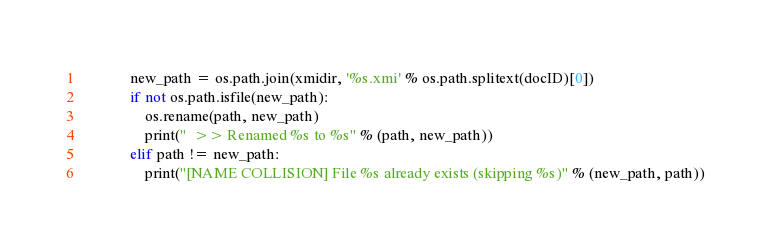Convert code to text. <code><loc_0><loc_0><loc_500><loc_500><_Python_>            new_path = os.path.join(xmidir, '%s.xmi' % os.path.splitext(docID)[0])
            if not os.path.isfile(new_path):
                os.rename(path, new_path)
                print("  >> Renamed %s to %s" % (path, new_path))
            elif path != new_path:
                print("[NAME COLLISION] File %s already exists (skipping %s)" % (new_path, path))
</code> 